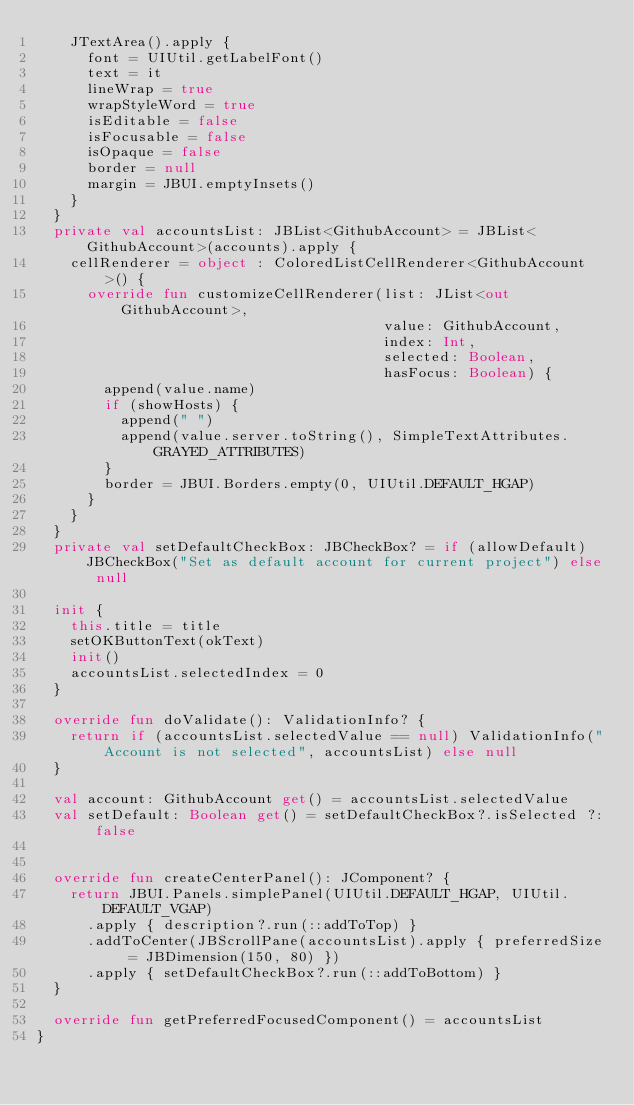<code> <loc_0><loc_0><loc_500><loc_500><_Kotlin_>    JTextArea().apply {
      font = UIUtil.getLabelFont()
      text = it
      lineWrap = true
      wrapStyleWord = true
      isEditable = false
      isFocusable = false
      isOpaque = false
      border = null
      margin = JBUI.emptyInsets()
    }
  }
  private val accountsList: JBList<GithubAccount> = JBList<GithubAccount>(accounts).apply {
    cellRenderer = object : ColoredListCellRenderer<GithubAccount>() {
      override fun customizeCellRenderer(list: JList<out GithubAccount>,
                                         value: GithubAccount,
                                         index: Int,
                                         selected: Boolean,
                                         hasFocus: Boolean) {
        append(value.name)
        if (showHosts) {
          append(" ")
          append(value.server.toString(), SimpleTextAttributes.GRAYED_ATTRIBUTES)
        }
        border = JBUI.Borders.empty(0, UIUtil.DEFAULT_HGAP)
      }
    }
  }
  private val setDefaultCheckBox: JBCheckBox? = if (allowDefault) JBCheckBox("Set as default account for current project") else null

  init {
    this.title = title
    setOKButtonText(okText)
    init()
    accountsList.selectedIndex = 0
  }

  override fun doValidate(): ValidationInfo? {
    return if (accountsList.selectedValue == null) ValidationInfo("Account is not selected", accountsList) else null
  }

  val account: GithubAccount get() = accountsList.selectedValue
  val setDefault: Boolean get() = setDefaultCheckBox?.isSelected ?: false


  override fun createCenterPanel(): JComponent? {
    return JBUI.Panels.simplePanel(UIUtil.DEFAULT_HGAP, UIUtil.DEFAULT_VGAP)
      .apply { description?.run(::addToTop) }
      .addToCenter(JBScrollPane(accountsList).apply { preferredSize = JBDimension(150, 80) })
      .apply { setDefaultCheckBox?.run(::addToBottom) }
  }

  override fun getPreferredFocusedComponent() = accountsList
}</code> 